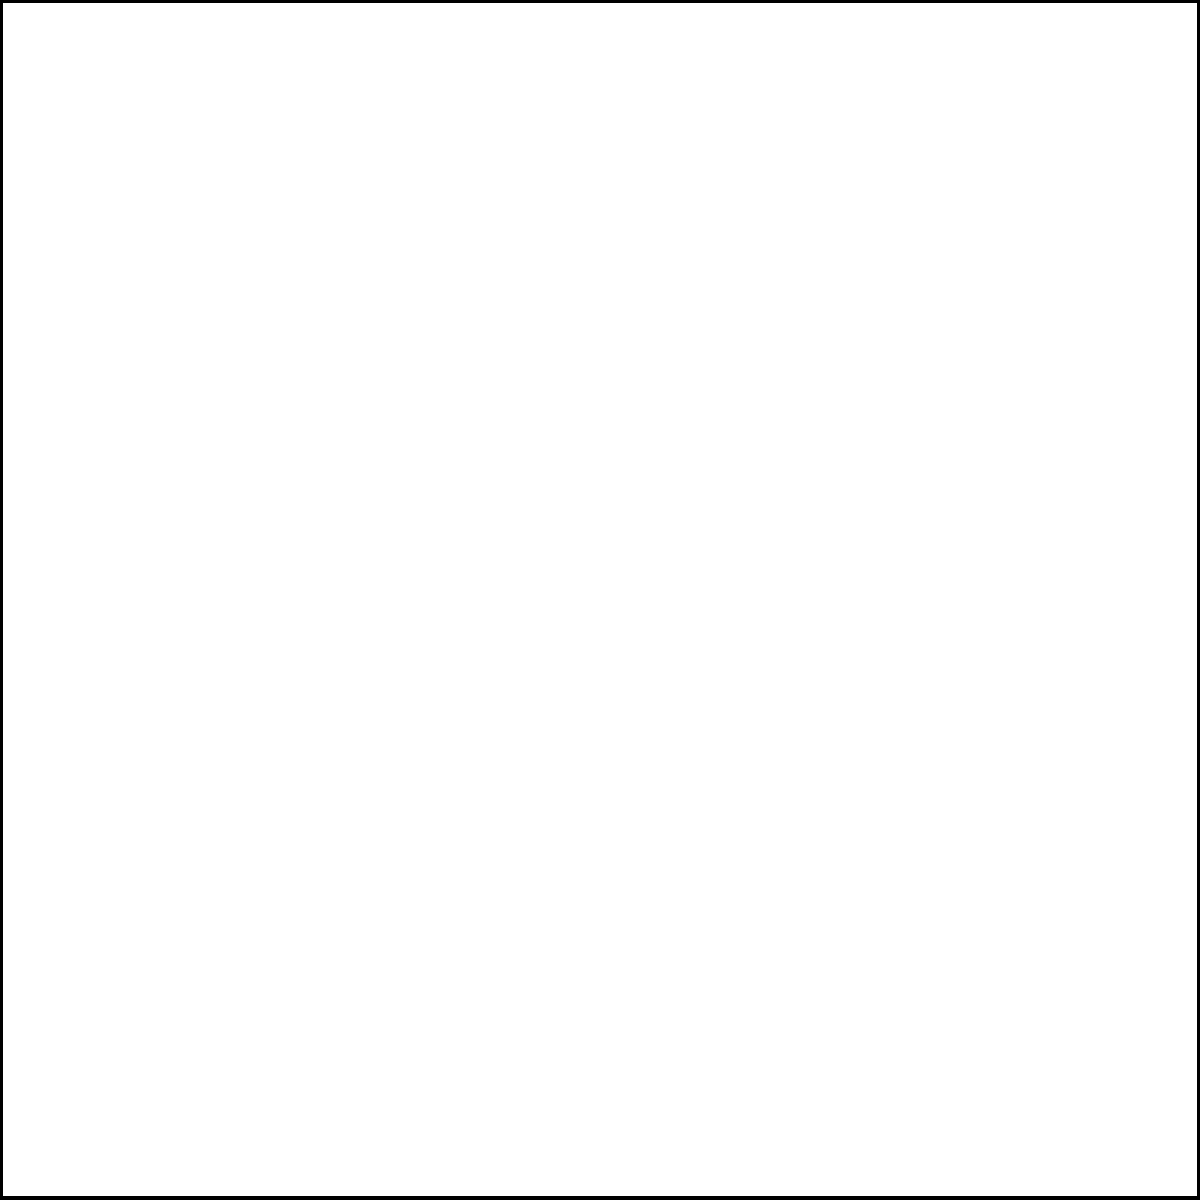In the diagram, the blue ellipse represents areas with high teenage pregnancy rates, and the red ellipse represents locations of youth-friendly health services in Uganda. What percentage of the total area of high teenage pregnancy rates (blue ellipse) overlaps with the area of youth-friendly health services (red ellipse)? To solve this problem, we need to follow these steps:

1. Understand the representation:
   - Blue ellipse: Areas with high teenage pregnancy rates
   - Red ellipse: Locations of youth-friendly health services
   - Overlap: Purple area where both ellipses intersect

2. Estimate the areas:
   - Total area of the blue ellipse: Let's assume it's 100 units^2
   - Area of overlap (purple): Let's estimate it's about 30 units^2

3. Calculate the percentage:
   - Percentage = (Area of overlap / Total area of blue ellipse) * 100
   - Percentage = (30 / 100) * 100 = 30%

4. Interpret the result:
   This means that approximately 30% of the areas with high teenage pregnancy rates have access to youth-friendly health services.

Note: The actual percentage may vary depending on the specific data for Uganda. This example uses estimated values for illustration purposes.
Answer: 30% 